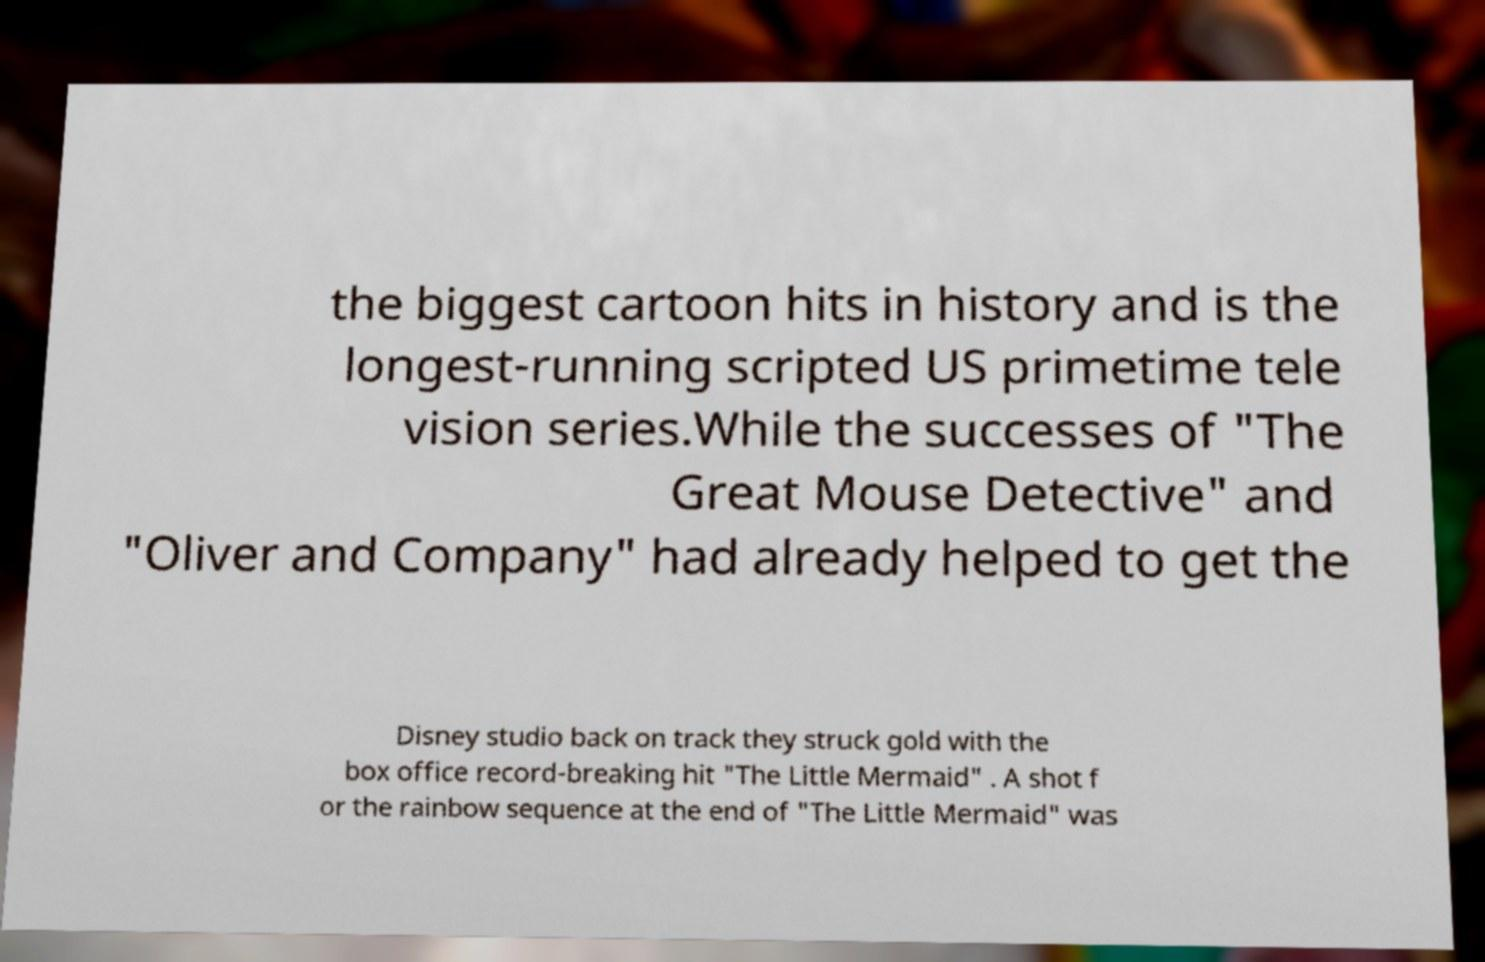Can you read and provide the text displayed in the image?This photo seems to have some interesting text. Can you extract and type it out for me? the biggest cartoon hits in history and is the longest-running scripted US primetime tele vision series.While the successes of "The Great Mouse Detective" and "Oliver and Company" had already helped to get the Disney studio back on track they struck gold with the box office record-breaking hit "The Little Mermaid" . A shot f or the rainbow sequence at the end of "The Little Mermaid" was 